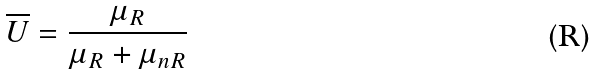<formula> <loc_0><loc_0><loc_500><loc_500>\overline { U } = \frac { \mu _ { R } } { \mu _ { R } + \mu _ { n R } }</formula> 